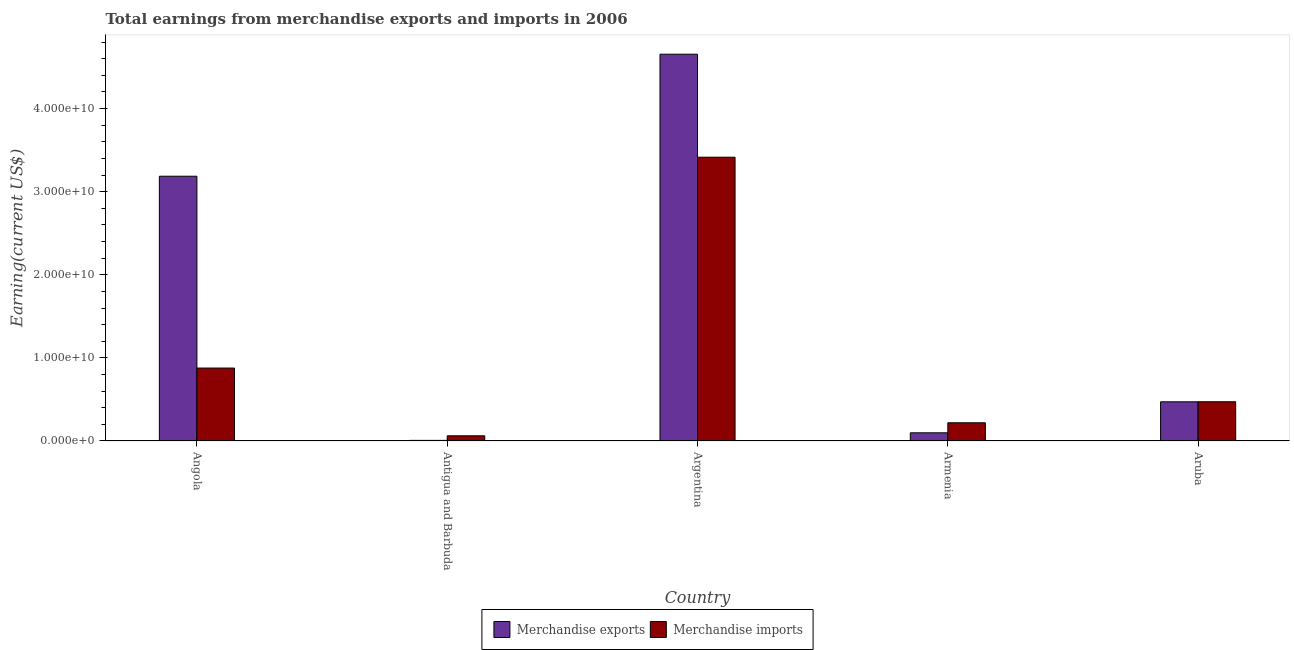How many groups of bars are there?
Ensure brevity in your answer.  5. Are the number of bars on each tick of the X-axis equal?
Your answer should be compact. Yes. How many bars are there on the 1st tick from the right?
Offer a terse response. 2. What is the label of the 5th group of bars from the left?
Provide a short and direct response. Aruba. What is the earnings from merchandise imports in Antigua and Barbuda?
Your answer should be very brief. 6.24e+08. Across all countries, what is the maximum earnings from merchandise exports?
Provide a short and direct response. 4.65e+1. Across all countries, what is the minimum earnings from merchandise exports?
Offer a terse response. 7.40e+07. In which country was the earnings from merchandise exports maximum?
Provide a short and direct response. Argentina. In which country was the earnings from merchandise exports minimum?
Keep it short and to the point. Antigua and Barbuda. What is the total earnings from merchandise exports in the graph?
Your answer should be compact. 8.42e+1. What is the difference between the earnings from merchandise exports in Antigua and Barbuda and that in Argentina?
Provide a short and direct response. -4.65e+1. What is the difference between the earnings from merchandise imports in Antigua and Barbuda and the earnings from merchandise exports in Armenia?
Provide a succinct answer. -3.61e+08. What is the average earnings from merchandise imports per country?
Keep it short and to the point. 1.01e+1. What is the difference between the earnings from merchandise imports and earnings from merchandise exports in Aruba?
Offer a very short reply. 6.76e+06. In how many countries, is the earnings from merchandise imports greater than 40000000000 US$?
Your response must be concise. 0. What is the ratio of the earnings from merchandise imports in Argentina to that in Armenia?
Your answer should be compact. 15.58. Is the difference between the earnings from merchandise exports in Argentina and Aruba greater than the difference between the earnings from merchandise imports in Argentina and Aruba?
Your answer should be compact. Yes. What is the difference between the highest and the second highest earnings from merchandise exports?
Your response must be concise. 1.47e+1. What is the difference between the highest and the lowest earnings from merchandise imports?
Your answer should be compact. 3.35e+1. Is the sum of the earnings from merchandise imports in Angola and Armenia greater than the maximum earnings from merchandise exports across all countries?
Make the answer very short. No. What does the 2nd bar from the left in Antigua and Barbuda represents?
Make the answer very short. Merchandise imports. What does the 2nd bar from the right in Antigua and Barbuda represents?
Offer a very short reply. Merchandise exports. How many bars are there?
Ensure brevity in your answer.  10. Are all the bars in the graph horizontal?
Ensure brevity in your answer.  No. How many countries are there in the graph?
Keep it short and to the point. 5. Are the values on the major ticks of Y-axis written in scientific E-notation?
Your answer should be very brief. Yes. Does the graph contain any zero values?
Offer a very short reply. No. Does the graph contain grids?
Offer a very short reply. No. What is the title of the graph?
Offer a terse response. Total earnings from merchandise exports and imports in 2006. Does "Highest 20% of population" appear as one of the legend labels in the graph?
Keep it short and to the point. No. What is the label or title of the Y-axis?
Provide a succinct answer. Earning(current US$). What is the Earning(current US$) in Merchandise exports in Angola?
Your response must be concise. 3.19e+1. What is the Earning(current US$) in Merchandise imports in Angola?
Provide a succinct answer. 8.78e+09. What is the Earning(current US$) in Merchandise exports in Antigua and Barbuda?
Offer a terse response. 7.40e+07. What is the Earning(current US$) in Merchandise imports in Antigua and Barbuda?
Give a very brief answer. 6.24e+08. What is the Earning(current US$) in Merchandise exports in Argentina?
Ensure brevity in your answer.  4.65e+1. What is the Earning(current US$) of Merchandise imports in Argentina?
Make the answer very short. 3.42e+1. What is the Earning(current US$) of Merchandise exports in Armenia?
Provide a succinct answer. 9.85e+08. What is the Earning(current US$) of Merchandise imports in Armenia?
Your answer should be compact. 2.19e+09. What is the Earning(current US$) in Merchandise exports in Aruba?
Ensure brevity in your answer.  4.72e+09. What is the Earning(current US$) in Merchandise imports in Aruba?
Offer a very short reply. 4.72e+09. Across all countries, what is the maximum Earning(current US$) in Merchandise exports?
Offer a terse response. 4.65e+1. Across all countries, what is the maximum Earning(current US$) of Merchandise imports?
Offer a terse response. 3.42e+1. Across all countries, what is the minimum Earning(current US$) of Merchandise exports?
Make the answer very short. 7.40e+07. Across all countries, what is the minimum Earning(current US$) in Merchandise imports?
Your response must be concise. 6.24e+08. What is the total Earning(current US$) of Merchandise exports in the graph?
Keep it short and to the point. 8.42e+1. What is the total Earning(current US$) of Merchandise imports in the graph?
Give a very brief answer. 5.05e+1. What is the difference between the Earning(current US$) in Merchandise exports in Angola and that in Antigua and Barbuda?
Ensure brevity in your answer.  3.18e+1. What is the difference between the Earning(current US$) of Merchandise imports in Angola and that in Antigua and Barbuda?
Give a very brief answer. 8.15e+09. What is the difference between the Earning(current US$) in Merchandise exports in Angola and that in Argentina?
Your answer should be very brief. -1.47e+1. What is the difference between the Earning(current US$) in Merchandise imports in Angola and that in Argentina?
Provide a succinct answer. -2.54e+1. What is the difference between the Earning(current US$) in Merchandise exports in Angola and that in Armenia?
Offer a terse response. 3.09e+1. What is the difference between the Earning(current US$) of Merchandise imports in Angola and that in Armenia?
Offer a very short reply. 6.59e+09. What is the difference between the Earning(current US$) of Merchandise exports in Angola and that in Aruba?
Ensure brevity in your answer.  2.71e+1. What is the difference between the Earning(current US$) of Merchandise imports in Angola and that in Aruba?
Make the answer very short. 4.05e+09. What is the difference between the Earning(current US$) in Merchandise exports in Antigua and Barbuda and that in Argentina?
Ensure brevity in your answer.  -4.65e+1. What is the difference between the Earning(current US$) in Merchandise imports in Antigua and Barbuda and that in Argentina?
Make the answer very short. -3.35e+1. What is the difference between the Earning(current US$) of Merchandise exports in Antigua and Barbuda and that in Armenia?
Offer a terse response. -9.11e+08. What is the difference between the Earning(current US$) in Merchandise imports in Antigua and Barbuda and that in Armenia?
Make the answer very short. -1.57e+09. What is the difference between the Earning(current US$) of Merchandise exports in Antigua and Barbuda and that in Aruba?
Make the answer very short. -4.64e+09. What is the difference between the Earning(current US$) in Merchandise imports in Antigua and Barbuda and that in Aruba?
Offer a terse response. -4.10e+09. What is the difference between the Earning(current US$) of Merchandise exports in Argentina and that in Armenia?
Your answer should be compact. 4.56e+1. What is the difference between the Earning(current US$) of Merchandise imports in Argentina and that in Armenia?
Offer a very short reply. 3.20e+1. What is the difference between the Earning(current US$) of Merchandise exports in Argentina and that in Aruba?
Ensure brevity in your answer.  4.18e+1. What is the difference between the Earning(current US$) of Merchandise imports in Argentina and that in Aruba?
Make the answer very short. 2.94e+1. What is the difference between the Earning(current US$) of Merchandise exports in Armenia and that in Aruba?
Give a very brief answer. -3.73e+09. What is the difference between the Earning(current US$) of Merchandise imports in Armenia and that in Aruba?
Keep it short and to the point. -2.53e+09. What is the difference between the Earning(current US$) in Merchandise exports in Angola and the Earning(current US$) in Merchandise imports in Antigua and Barbuda?
Give a very brief answer. 3.12e+1. What is the difference between the Earning(current US$) of Merchandise exports in Angola and the Earning(current US$) of Merchandise imports in Argentina?
Ensure brevity in your answer.  -2.29e+09. What is the difference between the Earning(current US$) of Merchandise exports in Angola and the Earning(current US$) of Merchandise imports in Armenia?
Provide a succinct answer. 2.97e+1. What is the difference between the Earning(current US$) in Merchandise exports in Angola and the Earning(current US$) in Merchandise imports in Aruba?
Your response must be concise. 2.71e+1. What is the difference between the Earning(current US$) in Merchandise exports in Antigua and Barbuda and the Earning(current US$) in Merchandise imports in Argentina?
Your answer should be compact. -3.41e+1. What is the difference between the Earning(current US$) in Merchandise exports in Antigua and Barbuda and the Earning(current US$) in Merchandise imports in Armenia?
Make the answer very short. -2.12e+09. What is the difference between the Earning(current US$) in Merchandise exports in Antigua and Barbuda and the Earning(current US$) in Merchandise imports in Aruba?
Your response must be concise. -4.65e+09. What is the difference between the Earning(current US$) of Merchandise exports in Argentina and the Earning(current US$) of Merchandise imports in Armenia?
Ensure brevity in your answer.  4.44e+1. What is the difference between the Earning(current US$) of Merchandise exports in Argentina and the Earning(current US$) of Merchandise imports in Aruba?
Your response must be concise. 4.18e+1. What is the difference between the Earning(current US$) of Merchandise exports in Armenia and the Earning(current US$) of Merchandise imports in Aruba?
Provide a short and direct response. -3.74e+09. What is the average Earning(current US$) of Merchandise exports per country?
Ensure brevity in your answer.  1.68e+1. What is the average Earning(current US$) in Merchandise imports per country?
Provide a short and direct response. 1.01e+1. What is the difference between the Earning(current US$) of Merchandise exports and Earning(current US$) of Merchandise imports in Angola?
Your response must be concise. 2.31e+1. What is the difference between the Earning(current US$) of Merchandise exports and Earning(current US$) of Merchandise imports in Antigua and Barbuda?
Keep it short and to the point. -5.50e+08. What is the difference between the Earning(current US$) in Merchandise exports and Earning(current US$) in Merchandise imports in Argentina?
Your answer should be compact. 1.24e+1. What is the difference between the Earning(current US$) in Merchandise exports and Earning(current US$) in Merchandise imports in Armenia?
Your response must be concise. -1.21e+09. What is the difference between the Earning(current US$) in Merchandise exports and Earning(current US$) in Merchandise imports in Aruba?
Ensure brevity in your answer.  -6.76e+06. What is the ratio of the Earning(current US$) in Merchandise exports in Angola to that in Antigua and Barbuda?
Make the answer very short. 430.57. What is the ratio of the Earning(current US$) of Merchandise imports in Angola to that in Antigua and Barbuda?
Provide a succinct answer. 14.06. What is the ratio of the Earning(current US$) of Merchandise exports in Angola to that in Argentina?
Your answer should be very brief. 0.68. What is the ratio of the Earning(current US$) of Merchandise imports in Angola to that in Argentina?
Your response must be concise. 0.26. What is the ratio of the Earning(current US$) in Merchandise exports in Angola to that in Armenia?
Keep it short and to the point. 32.34. What is the ratio of the Earning(current US$) of Merchandise imports in Angola to that in Armenia?
Ensure brevity in your answer.  4.01. What is the ratio of the Earning(current US$) in Merchandise exports in Angola to that in Aruba?
Give a very brief answer. 6.76. What is the ratio of the Earning(current US$) of Merchandise imports in Angola to that in Aruba?
Give a very brief answer. 1.86. What is the ratio of the Earning(current US$) in Merchandise exports in Antigua and Barbuda to that in Argentina?
Keep it short and to the point. 0. What is the ratio of the Earning(current US$) in Merchandise imports in Antigua and Barbuda to that in Argentina?
Keep it short and to the point. 0.02. What is the ratio of the Earning(current US$) in Merchandise exports in Antigua and Barbuda to that in Armenia?
Offer a terse response. 0.08. What is the ratio of the Earning(current US$) in Merchandise imports in Antigua and Barbuda to that in Armenia?
Give a very brief answer. 0.28. What is the ratio of the Earning(current US$) of Merchandise exports in Antigua and Barbuda to that in Aruba?
Your response must be concise. 0.02. What is the ratio of the Earning(current US$) of Merchandise imports in Antigua and Barbuda to that in Aruba?
Provide a succinct answer. 0.13. What is the ratio of the Earning(current US$) in Merchandise exports in Argentina to that in Armenia?
Make the answer very short. 47.25. What is the ratio of the Earning(current US$) of Merchandise imports in Argentina to that in Armenia?
Your answer should be very brief. 15.58. What is the ratio of the Earning(current US$) in Merchandise exports in Argentina to that in Aruba?
Ensure brevity in your answer.  9.87. What is the ratio of the Earning(current US$) of Merchandise imports in Argentina to that in Aruba?
Provide a succinct answer. 7.23. What is the ratio of the Earning(current US$) of Merchandise exports in Armenia to that in Aruba?
Your answer should be very brief. 0.21. What is the ratio of the Earning(current US$) in Merchandise imports in Armenia to that in Aruba?
Your answer should be very brief. 0.46. What is the difference between the highest and the second highest Earning(current US$) in Merchandise exports?
Provide a succinct answer. 1.47e+1. What is the difference between the highest and the second highest Earning(current US$) of Merchandise imports?
Your response must be concise. 2.54e+1. What is the difference between the highest and the lowest Earning(current US$) in Merchandise exports?
Offer a very short reply. 4.65e+1. What is the difference between the highest and the lowest Earning(current US$) in Merchandise imports?
Provide a succinct answer. 3.35e+1. 